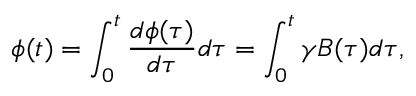Convert formula to latex. <formula><loc_0><loc_0><loc_500><loc_500>\phi ( t ) = \int _ { 0 } ^ { t } \frac { d \phi ( \tau ) } { d \tau } d \tau = \int _ { 0 } ^ { t } \gamma B ( \tau ) d \tau ,</formula> 